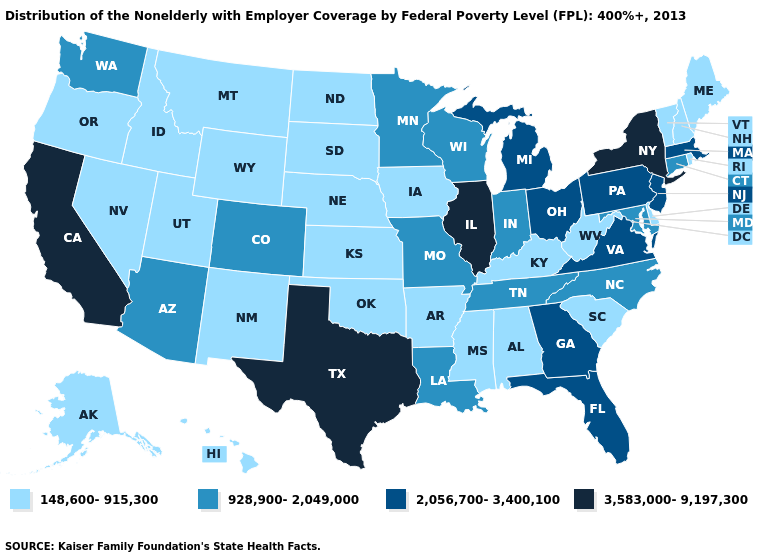What is the lowest value in the USA?
Write a very short answer. 148,600-915,300. Name the states that have a value in the range 148,600-915,300?
Write a very short answer. Alabama, Alaska, Arkansas, Delaware, Hawaii, Idaho, Iowa, Kansas, Kentucky, Maine, Mississippi, Montana, Nebraska, Nevada, New Hampshire, New Mexico, North Dakota, Oklahoma, Oregon, Rhode Island, South Carolina, South Dakota, Utah, Vermont, West Virginia, Wyoming. What is the lowest value in the South?
Short answer required. 148,600-915,300. What is the highest value in the MidWest ?
Be succinct. 3,583,000-9,197,300. Which states hav the highest value in the Northeast?
Write a very short answer. New York. What is the lowest value in the USA?
Quick response, please. 148,600-915,300. Does the first symbol in the legend represent the smallest category?
Be succinct. Yes. Which states have the lowest value in the Northeast?
Be succinct. Maine, New Hampshire, Rhode Island, Vermont. What is the lowest value in states that border Arkansas?
Answer briefly. 148,600-915,300. What is the value of Nevada?
Quick response, please. 148,600-915,300. What is the value of Texas?
Keep it brief. 3,583,000-9,197,300. Name the states that have a value in the range 928,900-2,049,000?
Give a very brief answer. Arizona, Colorado, Connecticut, Indiana, Louisiana, Maryland, Minnesota, Missouri, North Carolina, Tennessee, Washington, Wisconsin. Name the states that have a value in the range 928,900-2,049,000?
Give a very brief answer. Arizona, Colorado, Connecticut, Indiana, Louisiana, Maryland, Minnesota, Missouri, North Carolina, Tennessee, Washington, Wisconsin. Name the states that have a value in the range 3,583,000-9,197,300?
Answer briefly. California, Illinois, New York, Texas. Does the first symbol in the legend represent the smallest category?
Keep it brief. Yes. 